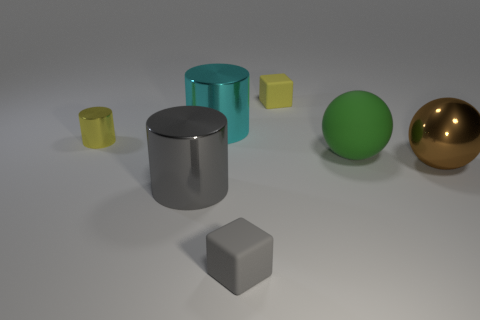Subtract all purple balls. Subtract all brown blocks. How many balls are left? 2 Add 1 small blocks. How many objects exist? 8 Subtract all blocks. How many objects are left? 5 Subtract all small brown metallic spheres. Subtract all large green matte objects. How many objects are left? 6 Add 4 large green matte balls. How many large green matte balls are left? 5 Add 3 cyan shiny cylinders. How many cyan shiny cylinders exist? 4 Subtract 0 purple cubes. How many objects are left? 7 